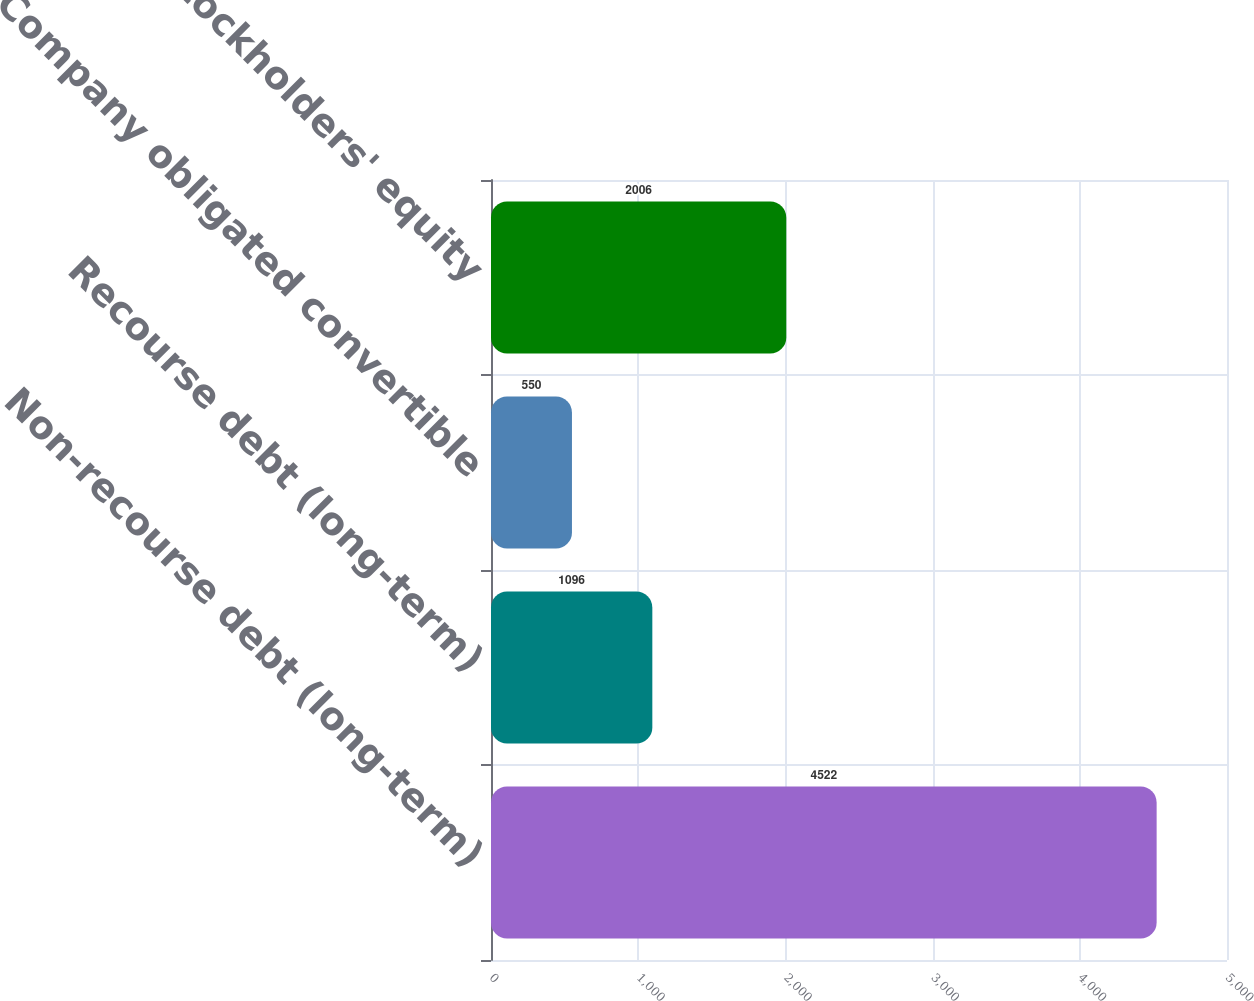Convert chart. <chart><loc_0><loc_0><loc_500><loc_500><bar_chart><fcel>Non-recourse debt (long-term)<fcel>Recourse debt (long-term)<fcel>Company obligated convertible<fcel>Stockholders' equity<nl><fcel>4522<fcel>1096<fcel>550<fcel>2006<nl></chart> 